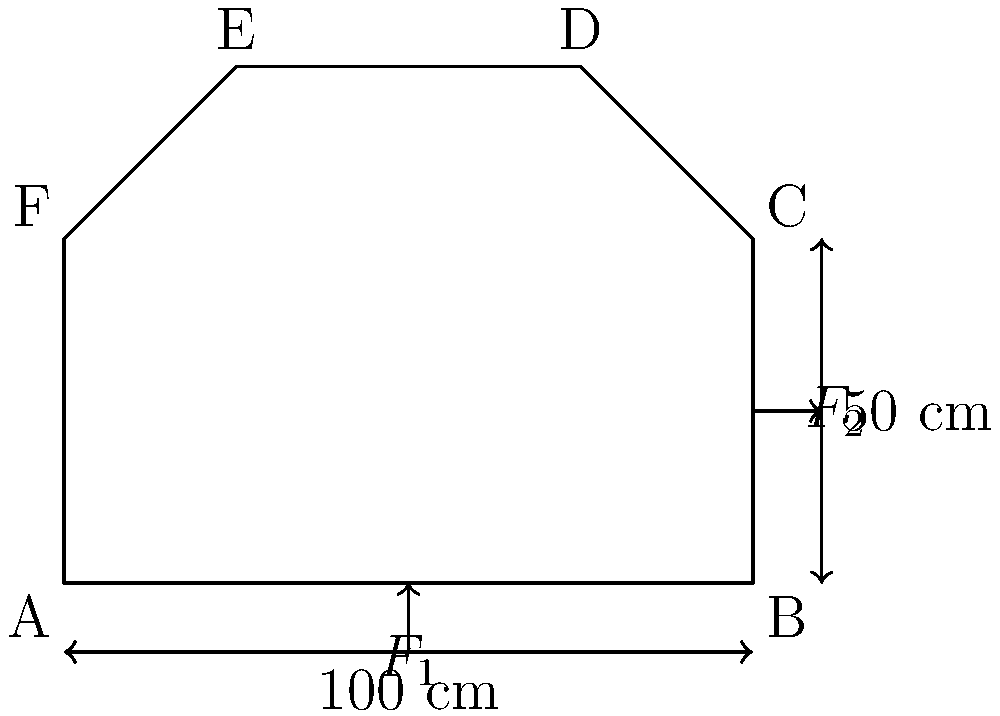A complex prop structure for a theater production is shown in the diagram. The structure is subjected to two forces: a vertical force $F_1 = 500$ N applied at the center of the base, and a horizontal force $F_2 = 300$ N applied at the midpoint of the right side. Assuming the prop is made of wood with a Young's modulus of $E = 11$ GPa and a cross-sectional area of $A = 25$ cm², calculate the maximum normal stress $\sigma_{max}$ in the structure. Consider both axial and bending stresses, and assume the prop behaves as a cantilever beam fixed at point A. To solve this problem, we'll follow these steps:

1) First, calculate the moment caused by the forces:
   $M = F_1 \cdot 50\text{ cm} + F_2 \cdot 50\text{ cm} = 500\text{ N} \cdot 0.5\text{ m} + 300\text{ N} \cdot 0.5\text{ m} = 400\text{ N}\cdot\text{m}$

2) The axial stress due to $F_1$ is:
   $\sigma_{axial} = \frac{F_1}{A} = \frac{500\text{ N}}{0.0025\text{ m}^2} = 200,000\text{ Pa} = 0.2\text{ MPa}$

3) For bending stress, we need the moment of inertia. Assuming a rectangular cross-section with height $h$ and width $b$:
   $I = \frac{bh^3}{12}$, where $bh = A = 0.0025\text{ m}^2$
   Let's assume $h = 2b$, then $2b^2 = 0.0025\text{ m}^2$, so $b = 0.0354\text{ m}$ and $h = 0.0707\text{ m}$
   $I = \frac{0.0354 \cdot 0.0707^3}{12} = 1.17 \times 10^{-6}\text{ m}^4$

4) The maximum bending stress occurs at the outer fibers:
   $\sigma_{bending} = \frac{My}{I} = \frac{400\text{ N}\cdot\text{m} \cdot 0.0354\text{ m}}{1.17 \times 10^{-6}\text{ m}^4} = 12.1\text{ MPa}$

5) The maximum normal stress is the sum of axial and bending stresses:
   $\sigma_{max} = \sigma_{axial} + \sigma_{bending} = 0.2\text{ MPa} + 12.1\text{ MPa} = 12.3\text{ MPa}$

Therefore, the maximum normal stress in the structure is approximately 12.3 MPa.
Answer: 12.3 MPa 